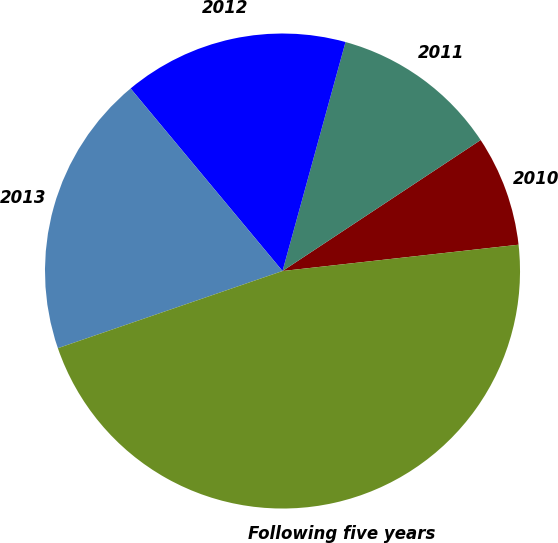<chart> <loc_0><loc_0><loc_500><loc_500><pie_chart><fcel>2010<fcel>2011<fcel>2012<fcel>2013<fcel>Following five years<nl><fcel>7.53%<fcel>11.43%<fcel>15.32%<fcel>19.22%<fcel>46.5%<nl></chart> 